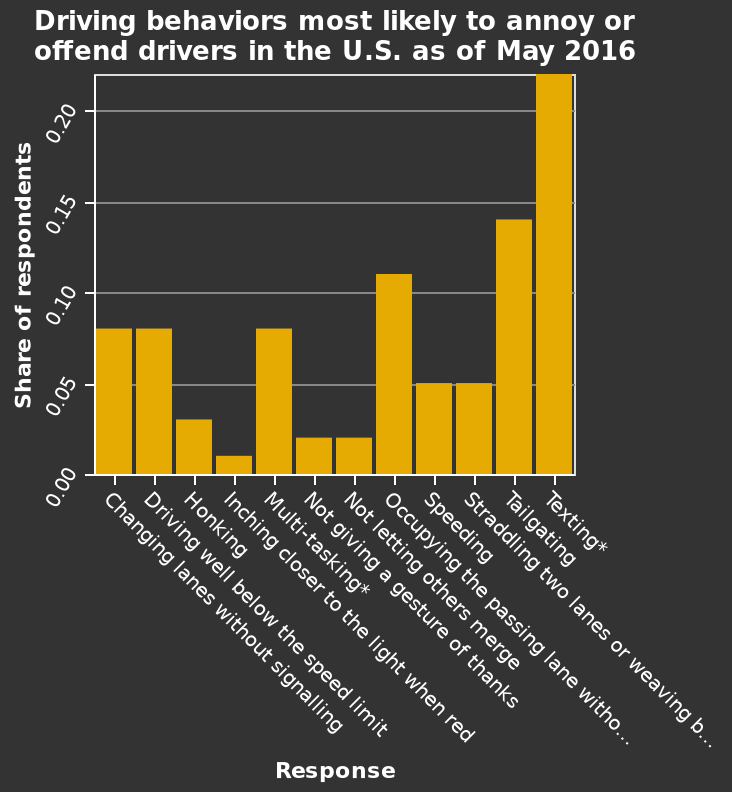<image>
Which behavior had a score below 5%? Inch closer to the red light was the behavior with a score below 5%. How does the score of texting behavior compare to others? The score of texting behavior was over 0.2, which was the highest. What does the y-axis represent in the bar chart? The y-axis represents the Share of respondents along a linear scale from 0.00 to 0.20. Does the y-axis represent the Share of respondents along a linear scale from 0.00 to 0.50? No.The y-axis represents the Share of respondents along a linear scale from 0.00 to 0.20. 